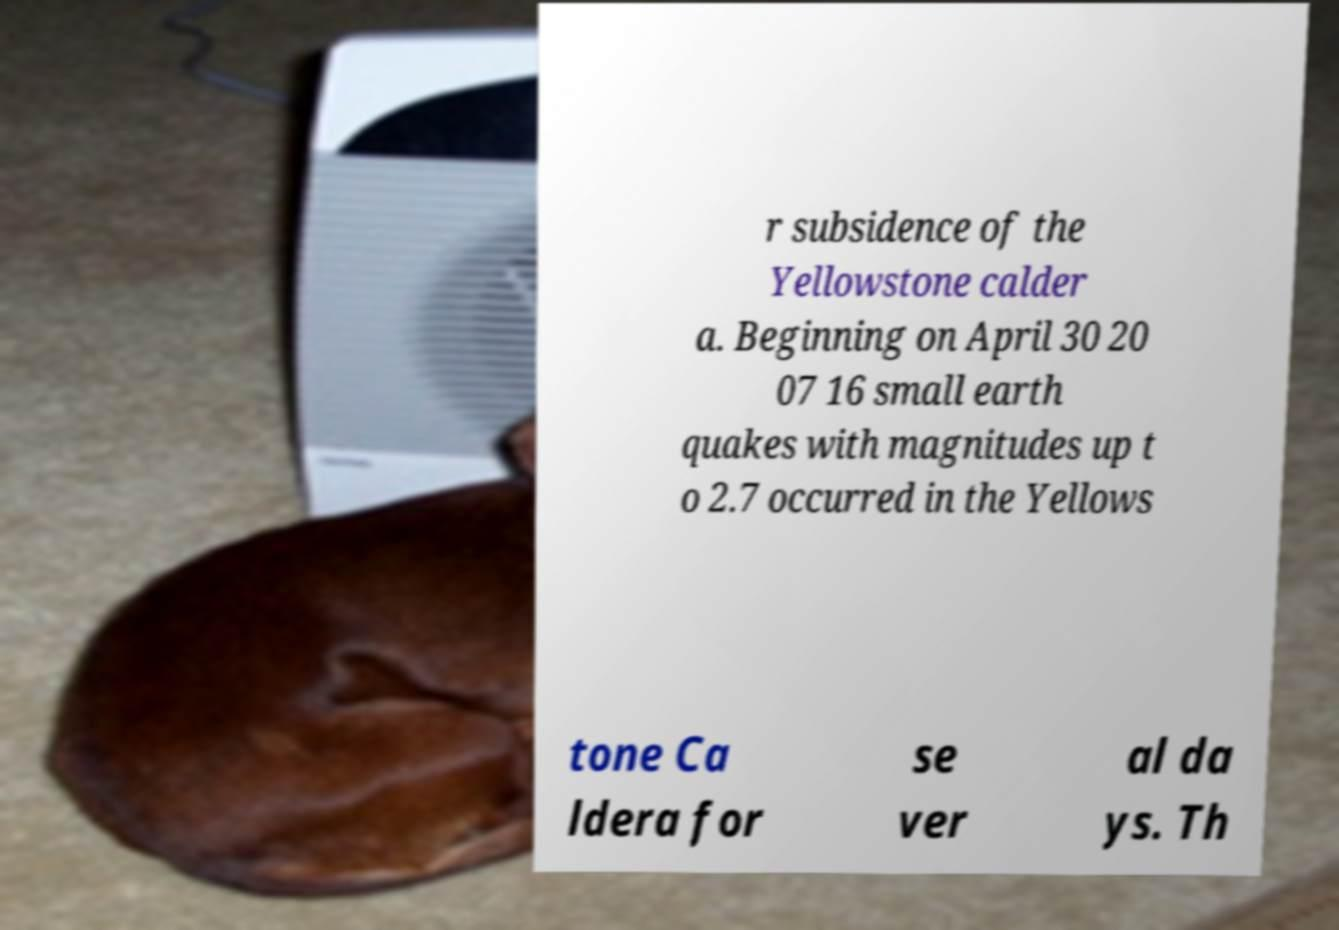Please identify and transcribe the text found in this image. r subsidence of the Yellowstone calder a. Beginning on April 30 20 07 16 small earth quakes with magnitudes up t o 2.7 occurred in the Yellows tone Ca ldera for se ver al da ys. Th 